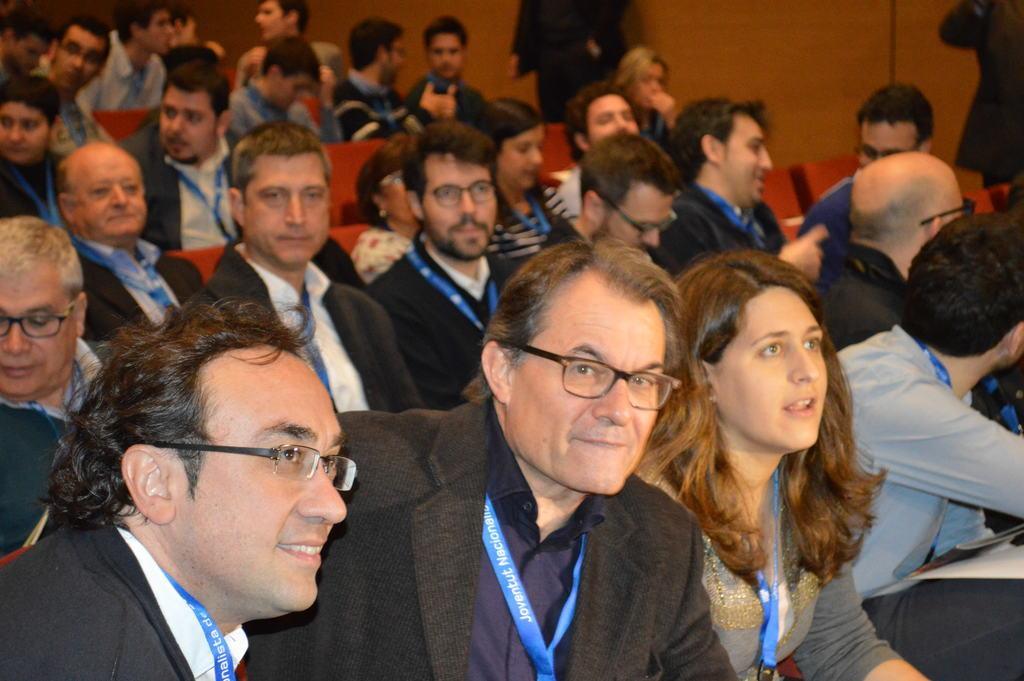Describe this image in one or two sentences. In the picture I can see people wearing dresses and identity cards are sitting on the chairs. The background of the image is slightly blurred, where I can see a few more people sitting on the chairs and a few more people standing. 